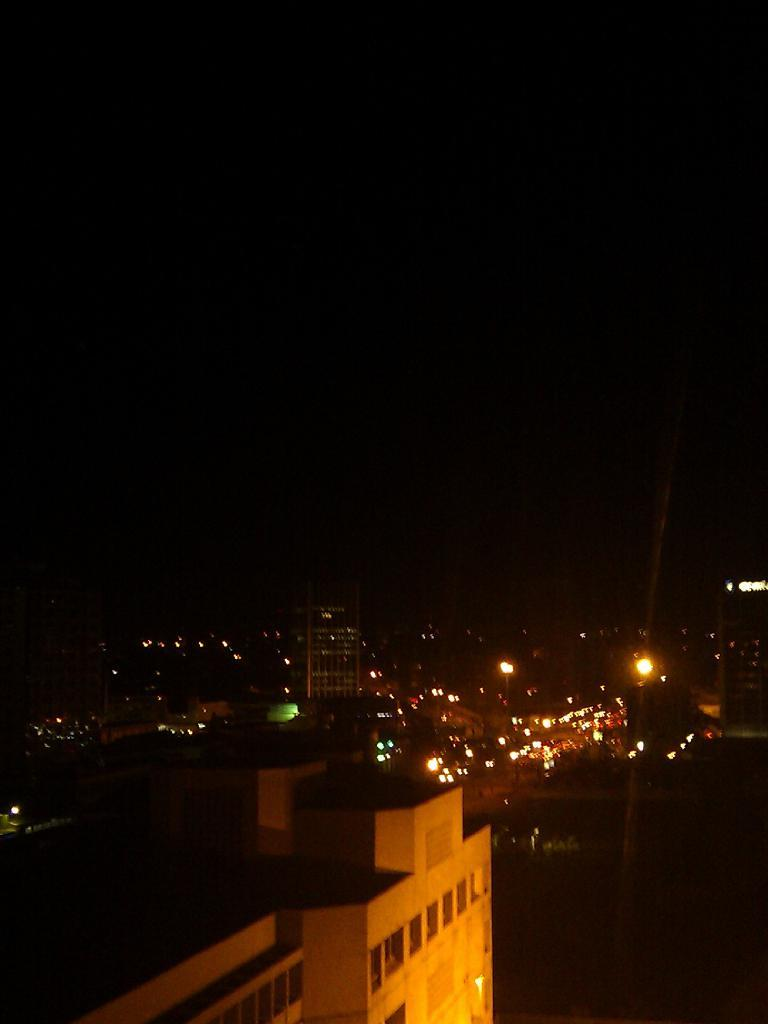What type of structures can be seen in the image? There are buildings and houses in the image. Are there any sources of illumination visible in the image? Yes, there are lights visible in the image. What is visible at the top of the image? The sky is visible at the top of the image. What type of cracker is being used to build the houses in the image? There is no cracker present in the image, and the houses are not being built. What mass is being measured in the image? There is no indication of any mass being measured in the image. 